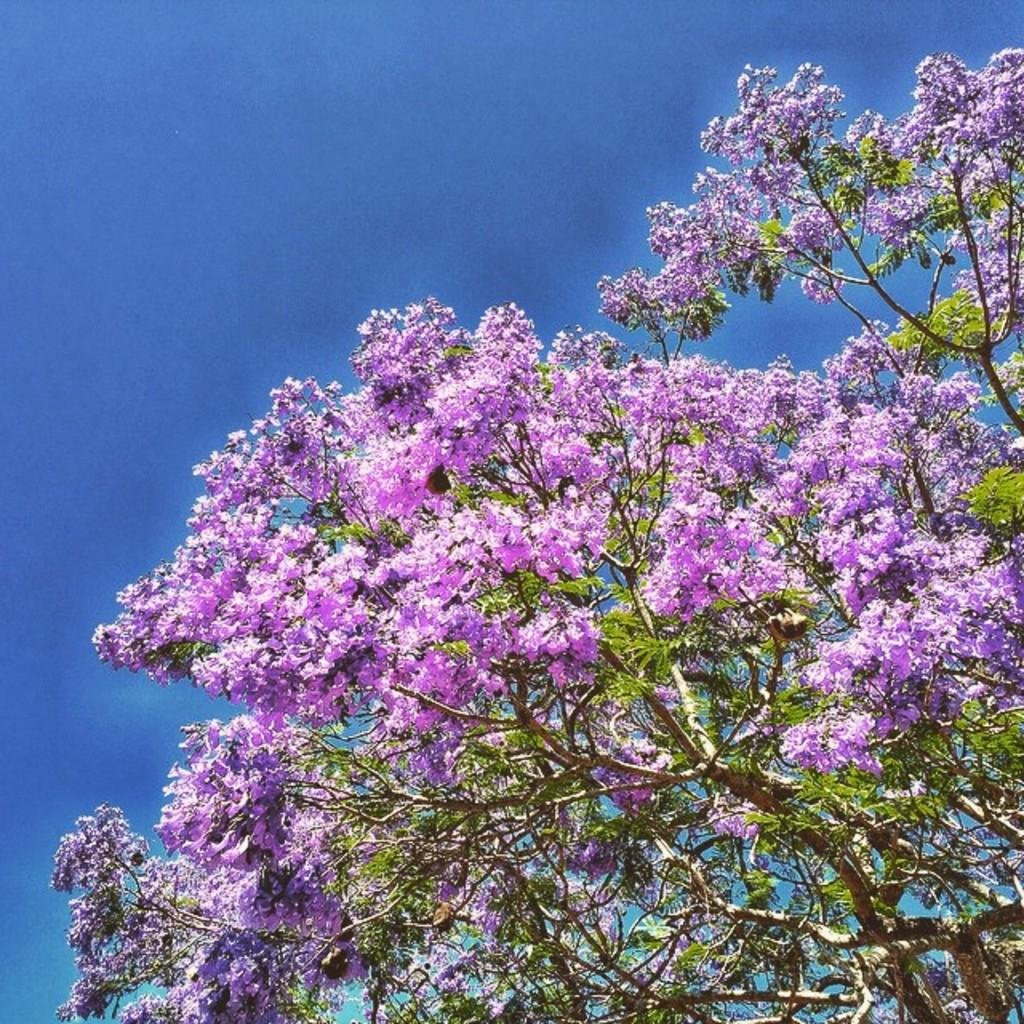What is the main subject of the image? There is a tree in the image. What is unique about the tree's appearance? The tree has blue flowers. What can be seen in the background of the image? There is a blue sky in the background of the image. How many crooks are hiding behind the tree in the image? There are no crooks present in the image; it features a tree with blue flowers and a blue sky in the background. 